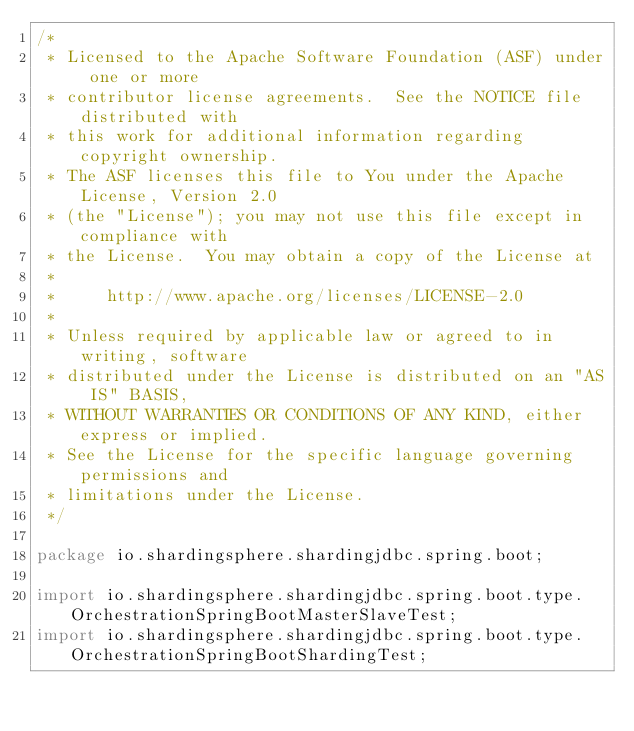Convert code to text. <code><loc_0><loc_0><loc_500><loc_500><_Java_>/*
 * Licensed to the Apache Software Foundation (ASF) under one or more
 * contributor license agreements.  See the NOTICE file distributed with
 * this work for additional information regarding copyright ownership.
 * The ASF licenses this file to You under the Apache License, Version 2.0
 * (the "License"); you may not use this file except in compliance with
 * the License.  You may obtain a copy of the License at
 *
 *     http://www.apache.org/licenses/LICENSE-2.0
 *
 * Unless required by applicable law or agreed to in writing, software
 * distributed under the License is distributed on an "AS IS" BASIS,
 * WITHOUT WARRANTIES OR CONDITIONS OF ANY KIND, either express or implied.
 * See the License for the specific language governing permissions and
 * limitations under the License.
 */

package io.shardingsphere.shardingjdbc.spring.boot;

import io.shardingsphere.shardingjdbc.spring.boot.type.OrchestrationSpringBootMasterSlaveTest;
import io.shardingsphere.shardingjdbc.spring.boot.type.OrchestrationSpringBootShardingTest;</code> 